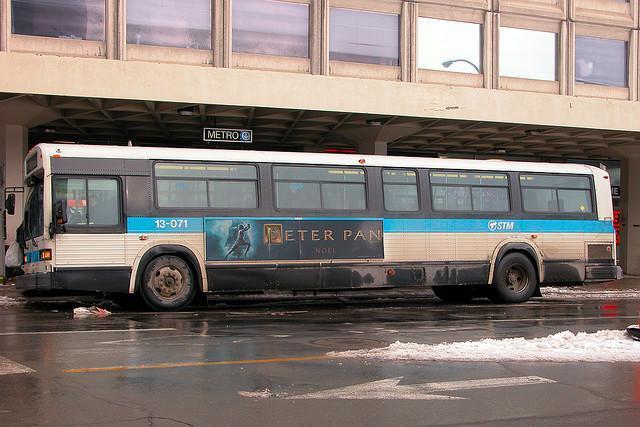How many people are in this picture?
Give a very brief answer. 0. 